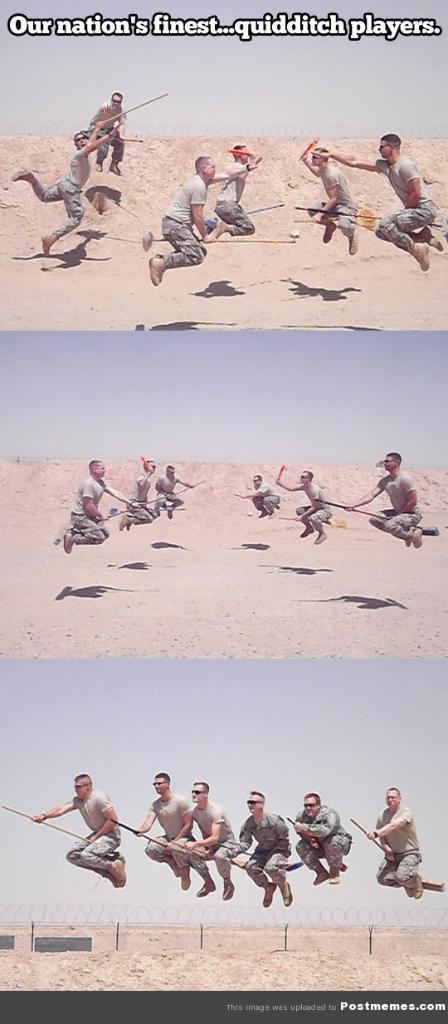<image>
Provide a brief description of the given image. "Our nation's finest...quidditch players." is on a picture of men on brooms. 